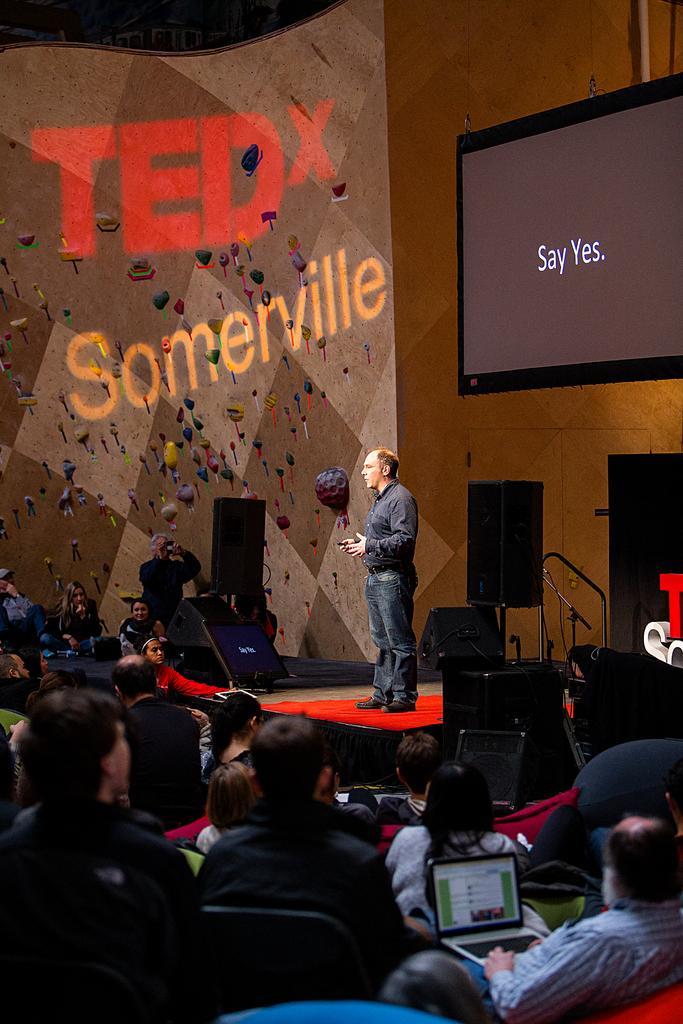How would you summarize this image in a sentence or two? Here we can see screens. On this stage a person is standing. Around this person there are speakers and monitor. Here we can see the audience. Few people are sitting on chairs. One person is working on his laptop.  